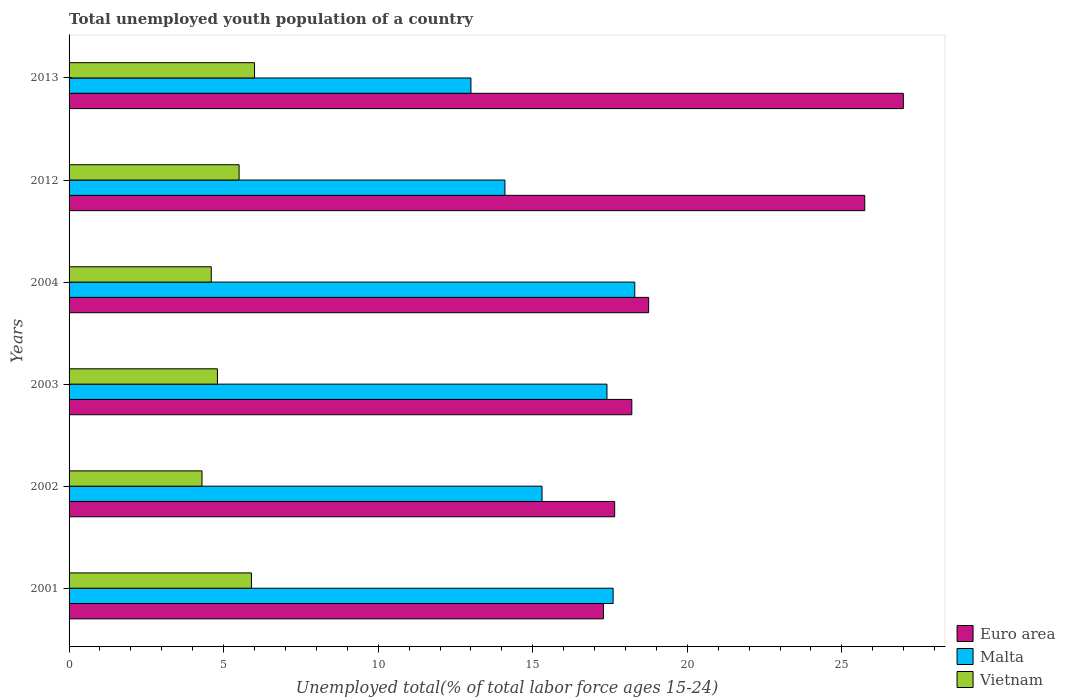How many groups of bars are there?
Your answer should be compact. 6. Are the number of bars on each tick of the Y-axis equal?
Ensure brevity in your answer.  Yes. How many bars are there on the 3rd tick from the top?
Give a very brief answer. 3. How many bars are there on the 2nd tick from the bottom?
Offer a very short reply. 3. What is the label of the 2nd group of bars from the top?
Make the answer very short. 2012. In how many cases, is the number of bars for a given year not equal to the number of legend labels?
Your answer should be compact. 0. What is the percentage of total unemployed youth population of a country in Euro area in 2013?
Keep it short and to the point. 26.99. Across all years, what is the maximum percentage of total unemployed youth population of a country in Euro area?
Your answer should be compact. 26.99. Across all years, what is the minimum percentage of total unemployed youth population of a country in Vietnam?
Ensure brevity in your answer.  4.3. In which year was the percentage of total unemployed youth population of a country in Vietnam maximum?
Offer a very short reply. 2013. What is the total percentage of total unemployed youth population of a country in Vietnam in the graph?
Provide a short and direct response. 31.1. What is the difference between the percentage of total unemployed youth population of a country in Vietnam in 2012 and that in 2013?
Offer a very short reply. -0.5. What is the difference between the percentage of total unemployed youth population of a country in Vietnam in 2013 and the percentage of total unemployed youth population of a country in Malta in 2012?
Provide a succinct answer. -8.1. What is the average percentage of total unemployed youth population of a country in Vietnam per year?
Give a very brief answer. 5.18. In the year 2013, what is the difference between the percentage of total unemployed youth population of a country in Euro area and percentage of total unemployed youth population of a country in Malta?
Give a very brief answer. 13.99. What is the ratio of the percentage of total unemployed youth population of a country in Vietnam in 2001 to that in 2013?
Your response must be concise. 0.98. Is the percentage of total unemployed youth population of a country in Vietnam in 2003 less than that in 2004?
Provide a succinct answer. No. Is the difference between the percentage of total unemployed youth population of a country in Euro area in 2003 and 2012 greater than the difference between the percentage of total unemployed youth population of a country in Malta in 2003 and 2012?
Your response must be concise. No. What is the difference between the highest and the second highest percentage of total unemployed youth population of a country in Vietnam?
Your answer should be very brief. 0.1. What is the difference between the highest and the lowest percentage of total unemployed youth population of a country in Vietnam?
Give a very brief answer. 1.7. In how many years, is the percentage of total unemployed youth population of a country in Euro area greater than the average percentage of total unemployed youth population of a country in Euro area taken over all years?
Your answer should be very brief. 2. What does the 2nd bar from the top in 2003 represents?
Your answer should be very brief. Malta. What does the 3rd bar from the bottom in 2013 represents?
Make the answer very short. Vietnam. How many bars are there?
Ensure brevity in your answer.  18. Are the values on the major ticks of X-axis written in scientific E-notation?
Offer a very short reply. No. Does the graph contain any zero values?
Give a very brief answer. No. Where does the legend appear in the graph?
Give a very brief answer. Bottom right. How are the legend labels stacked?
Offer a very short reply. Vertical. What is the title of the graph?
Make the answer very short. Total unemployed youth population of a country. Does "Caribbean small states" appear as one of the legend labels in the graph?
Your answer should be compact. No. What is the label or title of the X-axis?
Your answer should be very brief. Unemployed total(% of total labor force ages 15-24). What is the label or title of the Y-axis?
Provide a short and direct response. Years. What is the Unemployed total(% of total labor force ages 15-24) in Euro area in 2001?
Make the answer very short. 17.29. What is the Unemployed total(% of total labor force ages 15-24) in Malta in 2001?
Provide a succinct answer. 17.6. What is the Unemployed total(% of total labor force ages 15-24) of Vietnam in 2001?
Provide a succinct answer. 5.9. What is the Unemployed total(% of total labor force ages 15-24) of Euro area in 2002?
Provide a succinct answer. 17.65. What is the Unemployed total(% of total labor force ages 15-24) in Malta in 2002?
Your response must be concise. 15.3. What is the Unemployed total(% of total labor force ages 15-24) in Vietnam in 2002?
Provide a succinct answer. 4.3. What is the Unemployed total(% of total labor force ages 15-24) in Euro area in 2003?
Offer a terse response. 18.2. What is the Unemployed total(% of total labor force ages 15-24) in Malta in 2003?
Offer a very short reply. 17.4. What is the Unemployed total(% of total labor force ages 15-24) in Vietnam in 2003?
Provide a short and direct response. 4.8. What is the Unemployed total(% of total labor force ages 15-24) in Euro area in 2004?
Offer a very short reply. 18.75. What is the Unemployed total(% of total labor force ages 15-24) in Malta in 2004?
Ensure brevity in your answer.  18.3. What is the Unemployed total(% of total labor force ages 15-24) in Vietnam in 2004?
Your response must be concise. 4.6. What is the Unemployed total(% of total labor force ages 15-24) of Euro area in 2012?
Ensure brevity in your answer.  25.74. What is the Unemployed total(% of total labor force ages 15-24) in Malta in 2012?
Offer a terse response. 14.1. What is the Unemployed total(% of total labor force ages 15-24) in Vietnam in 2012?
Offer a terse response. 5.5. What is the Unemployed total(% of total labor force ages 15-24) in Euro area in 2013?
Your response must be concise. 26.99. What is the Unemployed total(% of total labor force ages 15-24) in Vietnam in 2013?
Make the answer very short. 6. Across all years, what is the maximum Unemployed total(% of total labor force ages 15-24) of Euro area?
Your response must be concise. 26.99. Across all years, what is the maximum Unemployed total(% of total labor force ages 15-24) in Malta?
Keep it short and to the point. 18.3. Across all years, what is the maximum Unemployed total(% of total labor force ages 15-24) in Vietnam?
Make the answer very short. 6. Across all years, what is the minimum Unemployed total(% of total labor force ages 15-24) of Euro area?
Ensure brevity in your answer.  17.29. Across all years, what is the minimum Unemployed total(% of total labor force ages 15-24) of Malta?
Make the answer very short. 13. Across all years, what is the minimum Unemployed total(% of total labor force ages 15-24) of Vietnam?
Give a very brief answer. 4.3. What is the total Unemployed total(% of total labor force ages 15-24) of Euro area in the graph?
Your answer should be compact. 124.62. What is the total Unemployed total(% of total labor force ages 15-24) of Malta in the graph?
Provide a short and direct response. 95.7. What is the total Unemployed total(% of total labor force ages 15-24) of Vietnam in the graph?
Provide a succinct answer. 31.1. What is the difference between the Unemployed total(% of total labor force ages 15-24) in Euro area in 2001 and that in 2002?
Provide a short and direct response. -0.36. What is the difference between the Unemployed total(% of total labor force ages 15-24) in Malta in 2001 and that in 2002?
Offer a terse response. 2.3. What is the difference between the Unemployed total(% of total labor force ages 15-24) of Vietnam in 2001 and that in 2002?
Your answer should be very brief. 1.6. What is the difference between the Unemployed total(% of total labor force ages 15-24) in Euro area in 2001 and that in 2003?
Make the answer very short. -0.92. What is the difference between the Unemployed total(% of total labor force ages 15-24) of Malta in 2001 and that in 2003?
Keep it short and to the point. 0.2. What is the difference between the Unemployed total(% of total labor force ages 15-24) in Euro area in 2001 and that in 2004?
Your response must be concise. -1.46. What is the difference between the Unemployed total(% of total labor force ages 15-24) of Malta in 2001 and that in 2004?
Ensure brevity in your answer.  -0.7. What is the difference between the Unemployed total(% of total labor force ages 15-24) in Vietnam in 2001 and that in 2004?
Your response must be concise. 1.3. What is the difference between the Unemployed total(% of total labor force ages 15-24) of Euro area in 2001 and that in 2012?
Offer a terse response. -8.45. What is the difference between the Unemployed total(% of total labor force ages 15-24) of Malta in 2001 and that in 2012?
Keep it short and to the point. 3.5. What is the difference between the Unemployed total(% of total labor force ages 15-24) of Euro area in 2001 and that in 2013?
Your answer should be very brief. -9.7. What is the difference between the Unemployed total(% of total labor force ages 15-24) in Vietnam in 2001 and that in 2013?
Make the answer very short. -0.1. What is the difference between the Unemployed total(% of total labor force ages 15-24) in Euro area in 2002 and that in 2003?
Provide a succinct answer. -0.56. What is the difference between the Unemployed total(% of total labor force ages 15-24) of Malta in 2002 and that in 2003?
Your answer should be compact. -2.1. What is the difference between the Unemployed total(% of total labor force ages 15-24) of Vietnam in 2002 and that in 2003?
Give a very brief answer. -0.5. What is the difference between the Unemployed total(% of total labor force ages 15-24) of Euro area in 2002 and that in 2004?
Provide a short and direct response. -1.1. What is the difference between the Unemployed total(% of total labor force ages 15-24) in Vietnam in 2002 and that in 2004?
Your answer should be very brief. -0.3. What is the difference between the Unemployed total(% of total labor force ages 15-24) in Euro area in 2002 and that in 2012?
Give a very brief answer. -8.09. What is the difference between the Unemployed total(% of total labor force ages 15-24) of Vietnam in 2002 and that in 2012?
Keep it short and to the point. -1.2. What is the difference between the Unemployed total(% of total labor force ages 15-24) in Euro area in 2002 and that in 2013?
Keep it short and to the point. -9.34. What is the difference between the Unemployed total(% of total labor force ages 15-24) of Vietnam in 2002 and that in 2013?
Your answer should be very brief. -1.7. What is the difference between the Unemployed total(% of total labor force ages 15-24) of Euro area in 2003 and that in 2004?
Ensure brevity in your answer.  -0.54. What is the difference between the Unemployed total(% of total labor force ages 15-24) in Euro area in 2003 and that in 2012?
Offer a very short reply. -7.54. What is the difference between the Unemployed total(% of total labor force ages 15-24) of Vietnam in 2003 and that in 2012?
Provide a short and direct response. -0.7. What is the difference between the Unemployed total(% of total labor force ages 15-24) of Euro area in 2003 and that in 2013?
Keep it short and to the point. -8.78. What is the difference between the Unemployed total(% of total labor force ages 15-24) of Vietnam in 2003 and that in 2013?
Provide a short and direct response. -1.2. What is the difference between the Unemployed total(% of total labor force ages 15-24) of Euro area in 2004 and that in 2012?
Your answer should be very brief. -6.99. What is the difference between the Unemployed total(% of total labor force ages 15-24) of Vietnam in 2004 and that in 2012?
Your answer should be very brief. -0.9. What is the difference between the Unemployed total(% of total labor force ages 15-24) in Euro area in 2004 and that in 2013?
Provide a short and direct response. -8.24. What is the difference between the Unemployed total(% of total labor force ages 15-24) in Vietnam in 2004 and that in 2013?
Your answer should be compact. -1.4. What is the difference between the Unemployed total(% of total labor force ages 15-24) in Euro area in 2012 and that in 2013?
Offer a terse response. -1.25. What is the difference between the Unemployed total(% of total labor force ages 15-24) in Euro area in 2001 and the Unemployed total(% of total labor force ages 15-24) in Malta in 2002?
Offer a terse response. 1.99. What is the difference between the Unemployed total(% of total labor force ages 15-24) in Euro area in 2001 and the Unemployed total(% of total labor force ages 15-24) in Vietnam in 2002?
Provide a short and direct response. 12.99. What is the difference between the Unemployed total(% of total labor force ages 15-24) of Euro area in 2001 and the Unemployed total(% of total labor force ages 15-24) of Malta in 2003?
Make the answer very short. -0.11. What is the difference between the Unemployed total(% of total labor force ages 15-24) of Euro area in 2001 and the Unemployed total(% of total labor force ages 15-24) of Vietnam in 2003?
Provide a succinct answer. 12.49. What is the difference between the Unemployed total(% of total labor force ages 15-24) in Malta in 2001 and the Unemployed total(% of total labor force ages 15-24) in Vietnam in 2003?
Your answer should be compact. 12.8. What is the difference between the Unemployed total(% of total labor force ages 15-24) in Euro area in 2001 and the Unemployed total(% of total labor force ages 15-24) in Malta in 2004?
Offer a terse response. -1.01. What is the difference between the Unemployed total(% of total labor force ages 15-24) of Euro area in 2001 and the Unemployed total(% of total labor force ages 15-24) of Vietnam in 2004?
Your answer should be very brief. 12.69. What is the difference between the Unemployed total(% of total labor force ages 15-24) of Euro area in 2001 and the Unemployed total(% of total labor force ages 15-24) of Malta in 2012?
Keep it short and to the point. 3.19. What is the difference between the Unemployed total(% of total labor force ages 15-24) in Euro area in 2001 and the Unemployed total(% of total labor force ages 15-24) in Vietnam in 2012?
Offer a terse response. 11.79. What is the difference between the Unemployed total(% of total labor force ages 15-24) of Euro area in 2001 and the Unemployed total(% of total labor force ages 15-24) of Malta in 2013?
Provide a succinct answer. 4.29. What is the difference between the Unemployed total(% of total labor force ages 15-24) in Euro area in 2001 and the Unemployed total(% of total labor force ages 15-24) in Vietnam in 2013?
Provide a short and direct response. 11.29. What is the difference between the Unemployed total(% of total labor force ages 15-24) of Euro area in 2002 and the Unemployed total(% of total labor force ages 15-24) of Malta in 2003?
Offer a terse response. 0.25. What is the difference between the Unemployed total(% of total labor force ages 15-24) of Euro area in 2002 and the Unemployed total(% of total labor force ages 15-24) of Vietnam in 2003?
Offer a terse response. 12.85. What is the difference between the Unemployed total(% of total labor force ages 15-24) of Malta in 2002 and the Unemployed total(% of total labor force ages 15-24) of Vietnam in 2003?
Make the answer very short. 10.5. What is the difference between the Unemployed total(% of total labor force ages 15-24) of Euro area in 2002 and the Unemployed total(% of total labor force ages 15-24) of Malta in 2004?
Ensure brevity in your answer.  -0.65. What is the difference between the Unemployed total(% of total labor force ages 15-24) in Euro area in 2002 and the Unemployed total(% of total labor force ages 15-24) in Vietnam in 2004?
Make the answer very short. 13.05. What is the difference between the Unemployed total(% of total labor force ages 15-24) in Euro area in 2002 and the Unemployed total(% of total labor force ages 15-24) in Malta in 2012?
Provide a short and direct response. 3.55. What is the difference between the Unemployed total(% of total labor force ages 15-24) of Euro area in 2002 and the Unemployed total(% of total labor force ages 15-24) of Vietnam in 2012?
Your answer should be very brief. 12.15. What is the difference between the Unemployed total(% of total labor force ages 15-24) of Malta in 2002 and the Unemployed total(% of total labor force ages 15-24) of Vietnam in 2012?
Your answer should be very brief. 9.8. What is the difference between the Unemployed total(% of total labor force ages 15-24) of Euro area in 2002 and the Unemployed total(% of total labor force ages 15-24) of Malta in 2013?
Give a very brief answer. 4.65. What is the difference between the Unemployed total(% of total labor force ages 15-24) in Euro area in 2002 and the Unemployed total(% of total labor force ages 15-24) in Vietnam in 2013?
Your response must be concise. 11.65. What is the difference between the Unemployed total(% of total labor force ages 15-24) of Malta in 2002 and the Unemployed total(% of total labor force ages 15-24) of Vietnam in 2013?
Your answer should be very brief. 9.3. What is the difference between the Unemployed total(% of total labor force ages 15-24) in Euro area in 2003 and the Unemployed total(% of total labor force ages 15-24) in Malta in 2004?
Provide a succinct answer. -0.1. What is the difference between the Unemployed total(% of total labor force ages 15-24) in Euro area in 2003 and the Unemployed total(% of total labor force ages 15-24) in Vietnam in 2004?
Give a very brief answer. 13.61. What is the difference between the Unemployed total(% of total labor force ages 15-24) in Malta in 2003 and the Unemployed total(% of total labor force ages 15-24) in Vietnam in 2004?
Your answer should be compact. 12.8. What is the difference between the Unemployed total(% of total labor force ages 15-24) of Euro area in 2003 and the Unemployed total(% of total labor force ages 15-24) of Malta in 2012?
Your answer should be very brief. 4.11. What is the difference between the Unemployed total(% of total labor force ages 15-24) of Euro area in 2003 and the Unemployed total(% of total labor force ages 15-24) of Vietnam in 2012?
Offer a very short reply. 12.71. What is the difference between the Unemployed total(% of total labor force ages 15-24) of Euro area in 2003 and the Unemployed total(% of total labor force ages 15-24) of Malta in 2013?
Ensure brevity in your answer.  5.21. What is the difference between the Unemployed total(% of total labor force ages 15-24) in Euro area in 2003 and the Unemployed total(% of total labor force ages 15-24) in Vietnam in 2013?
Make the answer very short. 12.21. What is the difference between the Unemployed total(% of total labor force ages 15-24) of Malta in 2003 and the Unemployed total(% of total labor force ages 15-24) of Vietnam in 2013?
Make the answer very short. 11.4. What is the difference between the Unemployed total(% of total labor force ages 15-24) in Euro area in 2004 and the Unemployed total(% of total labor force ages 15-24) in Malta in 2012?
Give a very brief answer. 4.65. What is the difference between the Unemployed total(% of total labor force ages 15-24) of Euro area in 2004 and the Unemployed total(% of total labor force ages 15-24) of Vietnam in 2012?
Your answer should be very brief. 13.25. What is the difference between the Unemployed total(% of total labor force ages 15-24) of Malta in 2004 and the Unemployed total(% of total labor force ages 15-24) of Vietnam in 2012?
Your response must be concise. 12.8. What is the difference between the Unemployed total(% of total labor force ages 15-24) in Euro area in 2004 and the Unemployed total(% of total labor force ages 15-24) in Malta in 2013?
Provide a short and direct response. 5.75. What is the difference between the Unemployed total(% of total labor force ages 15-24) of Euro area in 2004 and the Unemployed total(% of total labor force ages 15-24) of Vietnam in 2013?
Make the answer very short. 12.75. What is the difference between the Unemployed total(% of total labor force ages 15-24) in Malta in 2004 and the Unemployed total(% of total labor force ages 15-24) in Vietnam in 2013?
Provide a succinct answer. 12.3. What is the difference between the Unemployed total(% of total labor force ages 15-24) in Euro area in 2012 and the Unemployed total(% of total labor force ages 15-24) in Malta in 2013?
Provide a succinct answer. 12.74. What is the difference between the Unemployed total(% of total labor force ages 15-24) of Euro area in 2012 and the Unemployed total(% of total labor force ages 15-24) of Vietnam in 2013?
Keep it short and to the point. 19.74. What is the average Unemployed total(% of total labor force ages 15-24) in Euro area per year?
Provide a short and direct response. 20.77. What is the average Unemployed total(% of total labor force ages 15-24) in Malta per year?
Provide a succinct answer. 15.95. What is the average Unemployed total(% of total labor force ages 15-24) of Vietnam per year?
Offer a very short reply. 5.18. In the year 2001, what is the difference between the Unemployed total(% of total labor force ages 15-24) of Euro area and Unemployed total(% of total labor force ages 15-24) of Malta?
Keep it short and to the point. -0.31. In the year 2001, what is the difference between the Unemployed total(% of total labor force ages 15-24) in Euro area and Unemployed total(% of total labor force ages 15-24) in Vietnam?
Keep it short and to the point. 11.39. In the year 2001, what is the difference between the Unemployed total(% of total labor force ages 15-24) in Malta and Unemployed total(% of total labor force ages 15-24) in Vietnam?
Keep it short and to the point. 11.7. In the year 2002, what is the difference between the Unemployed total(% of total labor force ages 15-24) of Euro area and Unemployed total(% of total labor force ages 15-24) of Malta?
Your answer should be compact. 2.35. In the year 2002, what is the difference between the Unemployed total(% of total labor force ages 15-24) of Euro area and Unemployed total(% of total labor force ages 15-24) of Vietnam?
Provide a succinct answer. 13.35. In the year 2002, what is the difference between the Unemployed total(% of total labor force ages 15-24) of Malta and Unemployed total(% of total labor force ages 15-24) of Vietnam?
Make the answer very short. 11. In the year 2003, what is the difference between the Unemployed total(% of total labor force ages 15-24) of Euro area and Unemployed total(% of total labor force ages 15-24) of Malta?
Your answer should be very brief. 0.81. In the year 2003, what is the difference between the Unemployed total(% of total labor force ages 15-24) in Euro area and Unemployed total(% of total labor force ages 15-24) in Vietnam?
Give a very brief answer. 13.4. In the year 2004, what is the difference between the Unemployed total(% of total labor force ages 15-24) in Euro area and Unemployed total(% of total labor force ages 15-24) in Malta?
Make the answer very short. 0.45. In the year 2004, what is the difference between the Unemployed total(% of total labor force ages 15-24) of Euro area and Unemployed total(% of total labor force ages 15-24) of Vietnam?
Your response must be concise. 14.15. In the year 2012, what is the difference between the Unemployed total(% of total labor force ages 15-24) of Euro area and Unemployed total(% of total labor force ages 15-24) of Malta?
Keep it short and to the point. 11.64. In the year 2012, what is the difference between the Unemployed total(% of total labor force ages 15-24) in Euro area and Unemployed total(% of total labor force ages 15-24) in Vietnam?
Ensure brevity in your answer.  20.24. In the year 2012, what is the difference between the Unemployed total(% of total labor force ages 15-24) of Malta and Unemployed total(% of total labor force ages 15-24) of Vietnam?
Provide a short and direct response. 8.6. In the year 2013, what is the difference between the Unemployed total(% of total labor force ages 15-24) in Euro area and Unemployed total(% of total labor force ages 15-24) in Malta?
Your response must be concise. 13.99. In the year 2013, what is the difference between the Unemployed total(% of total labor force ages 15-24) of Euro area and Unemployed total(% of total labor force ages 15-24) of Vietnam?
Offer a terse response. 20.99. In the year 2013, what is the difference between the Unemployed total(% of total labor force ages 15-24) of Malta and Unemployed total(% of total labor force ages 15-24) of Vietnam?
Provide a short and direct response. 7. What is the ratio of the Unemployed total(% of total labor force ages 15-24) in Euro area in 2001 to that in 2002?
Give a very brief answer. 0.98. What is the ratio of the Unemployed total(% of total labor force ages 15-24) of Malta in 2001 to that in 2002?
Make the answer very short. 1.15. What is the ratio of the Unemployed total(% of total labor force ages 15-24) of Vietnam in 2001 to that in 2002?
Ensure brevity in your answer.  1.37. What is the ratio of the Unemployed total(% of total labor force ages 15-24) in Euro area in 2001 to that in 2003?
Provide a short and direct response. 0.95. What is the ratio of the Unemployed total(% of total labor force ages 15-24) of Malta in 2001 to that in 2003?
Make the answer very short. 1.01. What is the ratio of the Unemployed total(% of total labor force ages 15-24) in Vietnam in 2001 to that in 2003?
Provide a succinct answer. 1.23. What is the ratio of the Unemployed total(% of total labor force ages 15-24) in Euro area in 2001 to that in 2004?
Keep it short and to the point. 0.92. What is the ratio of the Unemployed total(% of total labor force ages 15-24) of Malta in 2001 to that in 2004?
Provide a short and direct response. 0.96. What is the ratio of the Unemployed total(% of total labor force ages 15-24) in Vietnam in 2001 to that in 2004?
Provide a short and direct response. 1.28. What is the ratio of the Unemployed total(% of total labor force ages 15-24) in Euro area in 2001 to that in 2012?
Keep it short and to the point. 0.67. What is the ratio of the Unemployed total(% of total labor force ages 15-24) of Malta in 2001 to that in 2012?
Give a very brief answer. 1.25. What is the ratio of the Unemployed total(% of total labor force ages 15-24) of Vietnam in 2001 to that in 2012?
Your answer should be very brief. 1.07. What is the ratio of the Unemployed total(% of total labor force ages 15-24) in Euro area in 2001 to that in 2013?
Your response must be concise. 0.64. What is the ratio of the Unemployed total(% of total labor force ages 15-24) of Malta in 2001 to that in 2013?
Ensure brevity in your answer.  1.35. What is the ratio of the Unemployed total(% of total labor force ages 15-24) in Vietnam in 2001 to that in 2013?
Your answer should be very brief. 0.98. What is the ratio of the Unemployed total(% of total labor force ages 15-24) of Euro area in 2002 to that in 2003?
Offer a terse response. 0.97. What is the ratio of the Unemployed total(% of total labor force ages 15-24) in Malta in 2002 to that in 2003?
Make the answer very short. 0.88. What is the ratio of the Unemployed total(% of total labor force ages 15-24) of Vietnam in 2002 to that in 2003?
Provide a succinct answer. 0.9. What is the ratio of the Unemployed total(% of total labor force ages 15-24) of Euro area in 2002 to that in 2004?
Your answer should be compact. 0.94. What is the ratio of the Unemployed total(% of total labor force ages 15-24) in Malta in 2002 to that in 2004?
Make the answer very short. 0.84. What is the ratio of the Unemployed total(% of total labor force ages 15-24) in Vietnam in 2002 to that in 2004?
Your response must be concise. 0.93. What is the ratio of the Unemployed total(% of total labor force ages 15-24) in Euro area in 2002 to that in 2012?
Provide a short and direct response. 0.69. What is the ratio of the Unemployed total(% of total labor force ages 15-24) of Malta in 2002 to that in 2012?
Make the answer very short. 1.09. What is the ratio of the Unemployed total(% of total labor force ages 15-24) of Vietnam in 2002 to that in 2012?
Ensure brevity in your answer.  0.78. What is the ratio of the Unemployed total(% of total labor force ages 15-24) in Euro area in 2002 to that in 2013?
Your answer should be very brief. 0.65. What is the ratio of the Unemployed total(% of total labor force ages 15-24) of Malta in 2002 to that in 2013?
Keep it short and to the point. 1.18. What is the ratio of the Unemployed total(% of total labor force ages 15-24) in Vietnam in 2002 to that in 2013?
Ensure brevity in your answer.  0.72. What is the ratio of the Unemployed total(% of total labor force ages 15-24) of Malta in 2003 to that in 2004?
Your answer should be compact. 0.95. What is the ratio of the Unemployed total(% of total labor force ages 15-24) of Vietnam in 2003 to that in 2004?
Give a very brief answer. 1.04. What is the ratio of the Unemployed total(% of total labor force ages 15-24) in Euro area in 2003 to that in 2012?
Provide a short and direct response. 0.71. What is the ratio of the Unemployed total(% of total labor force ages 15-24) of Malta in 2003 to that in 2012?
Provide a short and direct response. 1.23. What is the ratio of the Unemployed total(% of total labor force ages 15-24) in Vietnam in 2003 to that in 2012?
Offer a very short reply. 0.87. What is the ratio of the Unemployed total(% of total labor force ages 15-24) of Euro area in 2003 to that in 2013?
Provide a short and direct response. 0.67. What is the ratio of the Unemployed total(% of total labor force ages 15-24) in Malta in 2003 to that in 2013?
Offer a very short reply. 1.34. What is the ratio of the Unemployed total(% of total labor force ages 15-24) of Vietnam in 2003 to that in 2013?
Offer a very short reply. 0.8. What is the ratio of the Unemployed total(% of total labor force ages 15-24) in Euro area in 2004 to that in 2012?
Keep it short and to the point. 0.73. What is the ratio of the Unemployed total(% of total labor force ages 15-24) in Malta in 2004 to that in 2012?
Offer a very short reply. 1.3. What is the ratio of the Unemployed total(% of total labor force ages 15-24) in Vietnam in 2004 to that in 2012?
Your answer should be very brief. 0.84. What is the ratio of the Unemployed total(% of total labor force ages 15-24) of Euro area in 2004 to that in 2013?
Your answer should be compact. 0.69. What is the ratio of the Unemployed total(% of total labor force ages 15-24) in Malta in 2004 to that in 2013?
Keep it short and to the point. 1.41. What is the ratio of the Unemployed total(% of total labor force ages 15-24) in Vietnam in 2004 to that in 2013?
Make the answer very short. 0.77. What is the ratio of the Unemployed total(% of total labor force ages 15-24) in Euro area in 2012 to that in 2013?
Your response must be concise. 0.95. What is the ratio of the Unemployed total(% of total labor force ages 15-24) of Malta in 2012 to that in 2013?
Provide a short and direct response. 1.08. What is the ratio of the Unemployed total(% of total labor force ages 15-24) of Vietnam in 2012 to that in 2013?
Ensure brevity in your answer.  0.92. What is the difference between the highest and the second highest Unemployed total(% of total labor force ages 15-24) of Euro area?
Provide a short and direct response. 1.25. What is the difference between the highest and the second highest Unemployed total(% of total labor force ages 15-24) in Malta?
Offer a very short reply. 0.7. What is the difference between the highest and the lowest Unemployed total(% of total labor force ages 15-24) of Euro area?
Make the answer very short. 9.7. What is the difference between the highest and the lowest Unemployed total(% of total labor force ages 15-24) of Vietnam?
Your response must be concise. 1.7. 